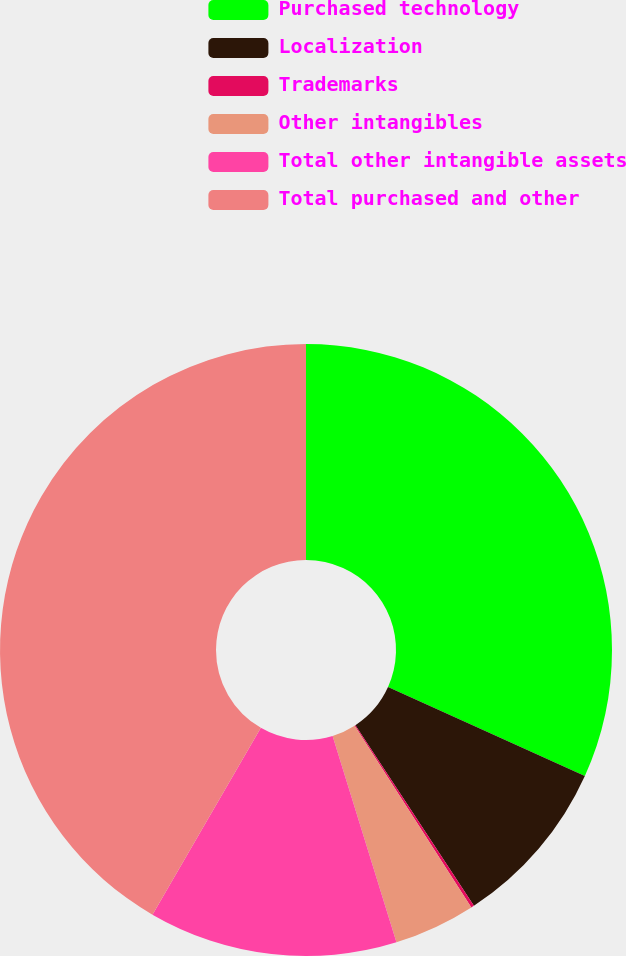<chart> <loc_0><loc_0><loc_500><loc_500><pie_chart><fcel>Purchased technology<fcel>Localization<fcel>Trademarks<fcel>Other intangibles<fcel>Total other intangible assets<fcel>Total purchased and other<nl><fcel>31.75%<fcel>9.0%<fcel>0.16%<fcel>4.31%<fcel>13.14%<fcel>41.63%<nl></chart> 